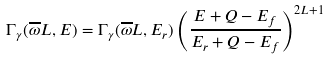<formula> <loc_0><loc_0><loc_500><loc_500>\Gamma _ { \gamma } ( \overline { \omega } L , E ) = \Gamma _ { \gamma } ( \overline { \omega } L , E _ { r } ) \left ( \frac { E + Q - E _ { f } } { E _ { r } + Q - E _ { f } } \right ) ^ { 2 L + 1 }</formula> 